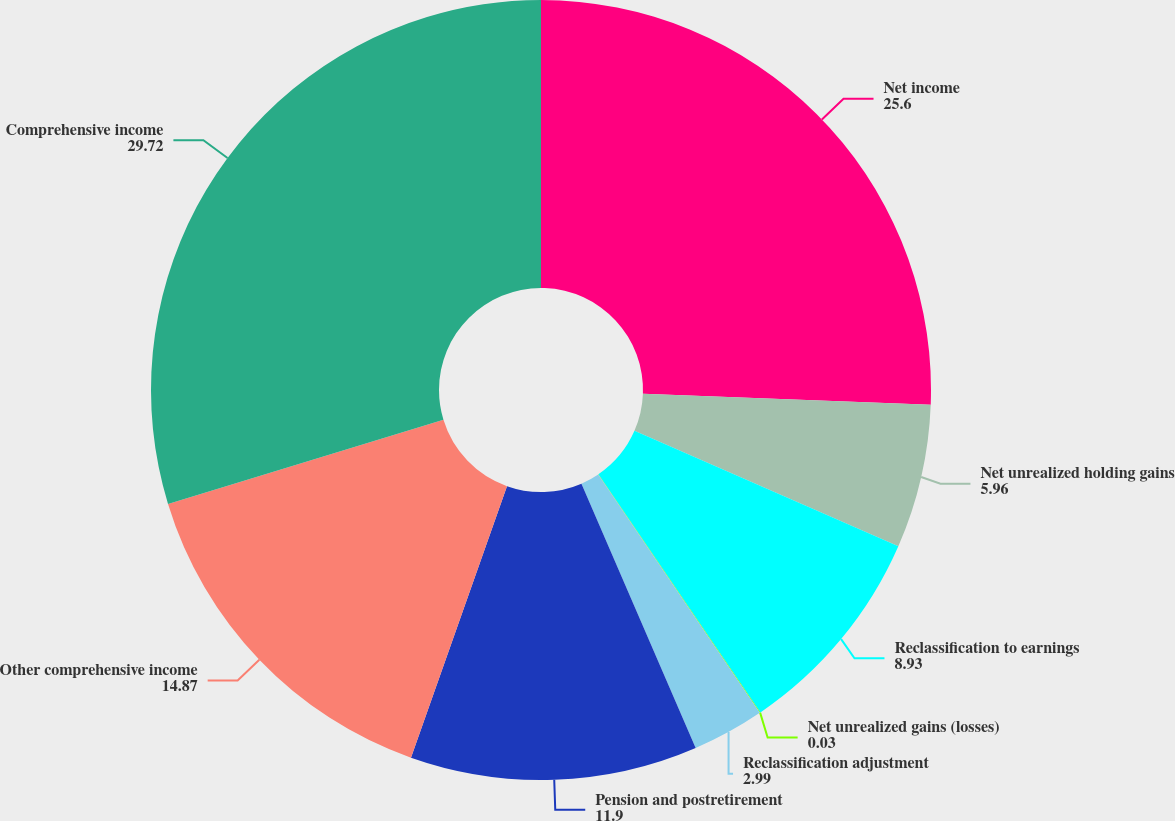Convert chart to OTSL. <chart><loc_0><loc_0><loc_500><loc_500><pie_chart><fcel>Net income<fcel>Net unrealized holding gains<fcel>Reclassification to earnings<fcel>Net unrealized gains (losses)<fcel>Reclassification adjustment<fcel>Pension and postretirement<fcel>Other comprehensive income<fcel>Comprehensive income<nl><fcel>25.6%<fcel>5.96%<fcel>8.93%<fcel>0.03%<fcel>2.99%<fcel>11.9%<fcel>14.87%<fcel>29.72%<nl></chart> 